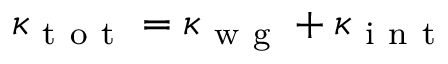<formula> <loc_0><loc_0><loc_500><loc_500>\kappa _ { t o t } = \kappa _ { w g } + \kappa _ { i n t }</formula> 